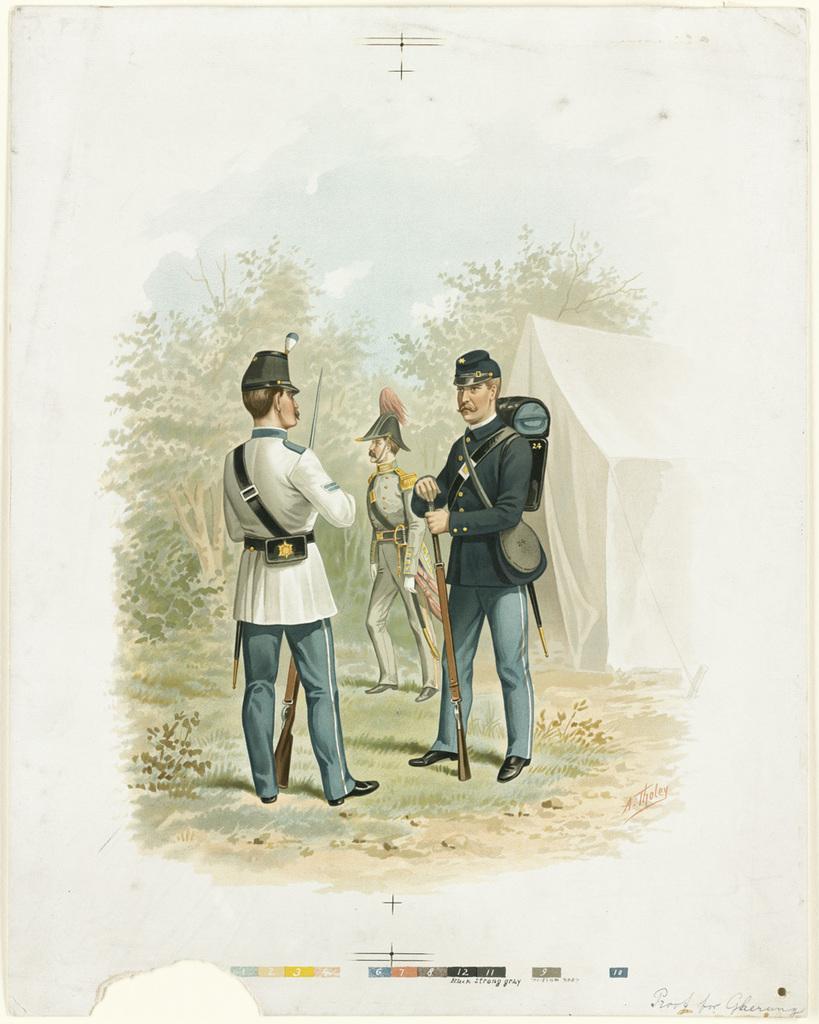In one or two sentences, can you explain what this image depicts? This is a painting and in this painting we can see three men wore caps and holding guns with their hands and standing on the ground, trees, tent, sky. 